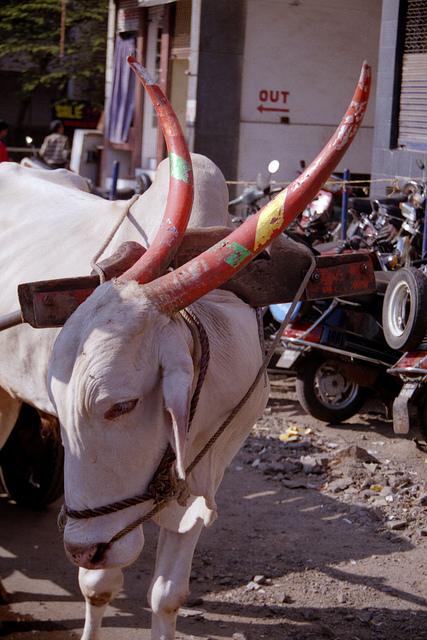Are the animals horns painted?
Be succinct. Yes. How many horns are visible?
Quick response, please. 2. What does the arrow on the building represent?
Keep it brief. Out. How many animals are depicted?
Be succinct. 1. What is the color of the closest animal?
Concise answer only. White. 